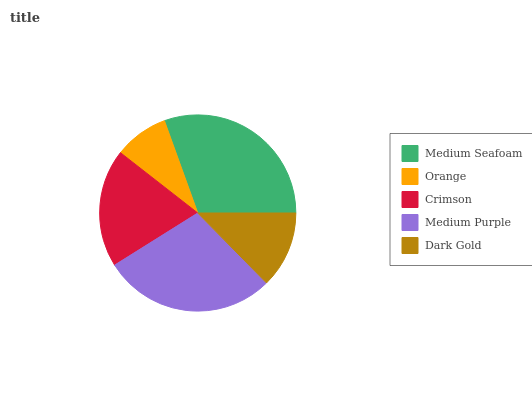Is Orange the minimum?
Answer yes or no. Yes. Is Medium Seafoam the maximum?
Answer yes or no. Yes. Is Crimson the minimum?
Answer yes or no. No. Is Crimson the maximum?
Answer yes or no. No. Is Crimson greater than Orange?
Answer yes or no. Yes. Is Orange less than Crimson?
Answer yes or no. Yes. Is Orange greater than Crimson?
Answer yes or no. No. Is Crimson less than Orange?
Answer yes or no. No. Is Crimson the high median?
Answer yes or no. Yes. Is Crimson the low median?
Answer yes or no. Yes. Is Dark Gold the high median?
Answer yes or no. No. Is Medium Purple the low median?
Answer yes or no. No. 